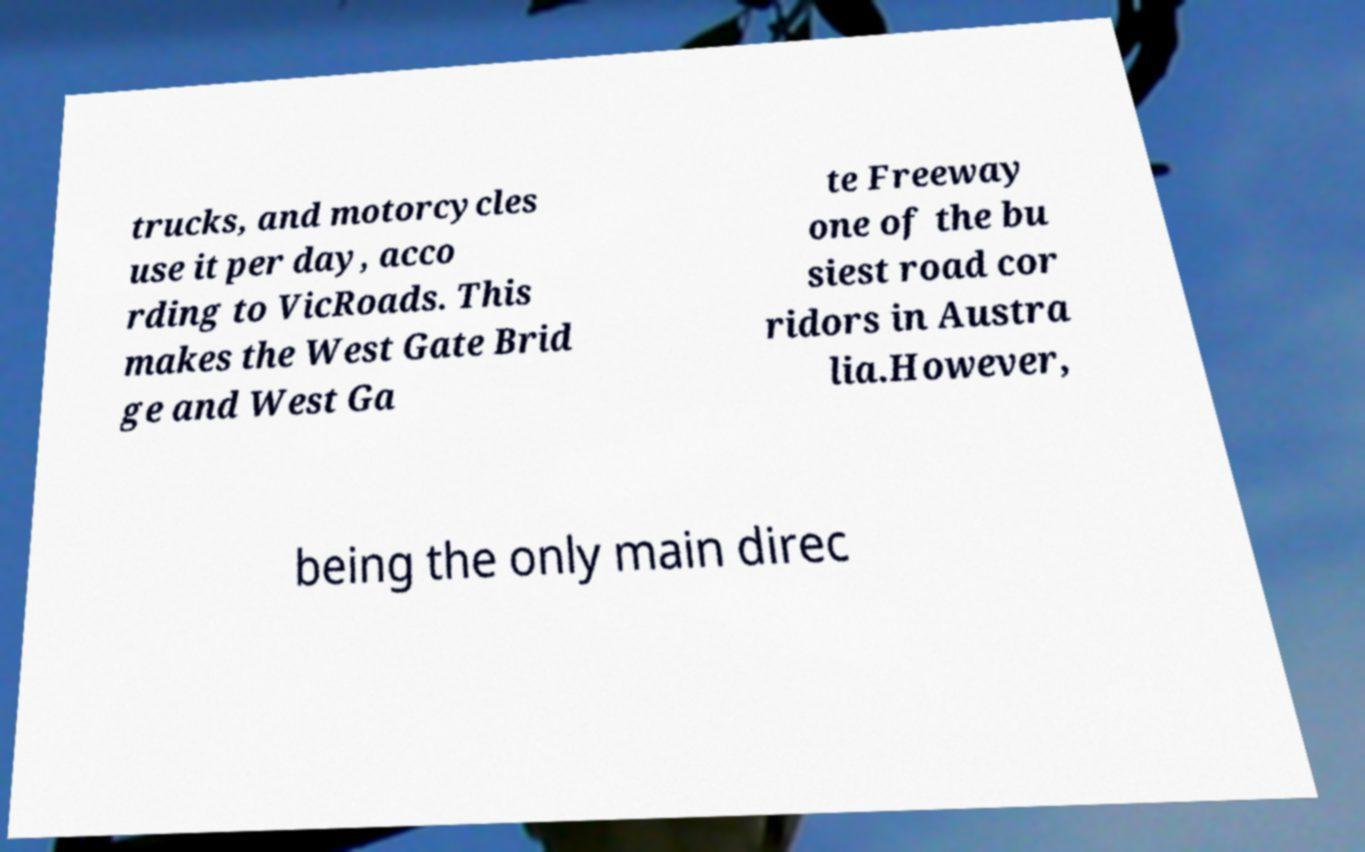Can you read and provide the text displayed in the image?This photo seems to have some interesting text. Can you extract and type it out for me? trucks, and motorcycles use it per day, acco rding to VicRoads. This makes the West Gate Brid ge and West Ga te Freeway one of the bu siest road cor ridors in Austra lia.However, being the only main direc 